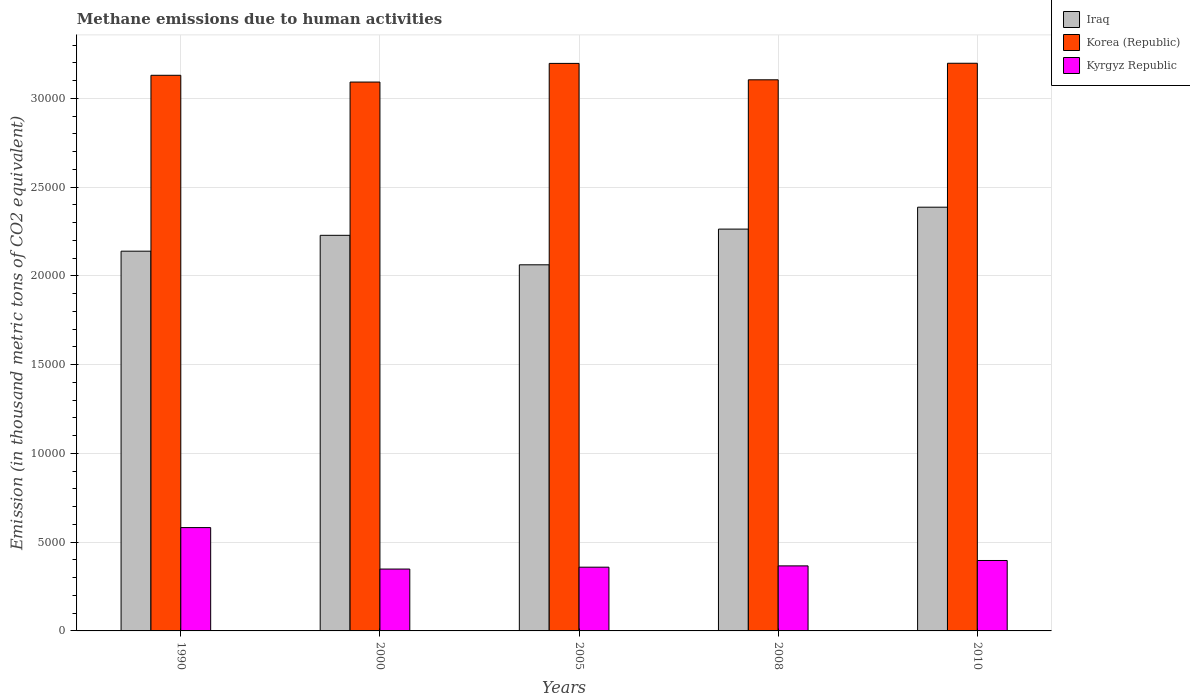How many groups of bars are there?
Give a very brief answer. 5. Are the number of bars on each tick of the X-axis equal?
Offer a very short reply. Yes. In how many cases, is the number of bars for a given year not equal to the number of legend labels?
Provide a succinct answer. 0. What is the amount of methane emitted in Kyrgyz Republic in 1990?
Provide a short and direct response. 5822.6. Across all years, what is the maximum amount of methane emitted in Korea (Republic)?
Offer a terse response. 3.20e+04. Across all years, what is the minimum amount of methane emitted in Kyrgyz Republic?
Offer a terse response. 3485.8. In which year was the amount of methane emitted in Iraq maximum?
Provide a short and direct response. 2010. In which year was the amount of methane emitted in Korea (Republic) minimum?
Ensure brevity in your answer.  2000. What is the total amount of methane emitted in Kyrgyz Republic in the graph?
Your answer should be compact. 2.05e+04. What is the difference between the amount of methane emitted in Korea (Republic) in 2000 and that in 2010?
Your response must be concise. -1058.8. What is the difference between the amount of methane emitted in Korea (Republic) in 2008 and the amount of methane emitted in Kyrgyz Republic in 1990?
Offer a terse response. 2.52e+04. What is the average amount of methane emitted in Korea (Republic) per year?
Give a very brief answer. 3.14e+04. In the year 1990, what is the difference between the amount of methane emitted in Iraq and amount of methane emitted in Korea (Republic)?
Give a very brief answer. -9910.7. In how many years, is the amount of methane emitted in Kyrgyz Republic greater than 9000 thousand metric tons?
Your answer should be compact. 0. What is the ratio of the amount of methane emitted in Korea (Republic) in 2008 to that in 2010?
Keep it short and to the point. 0.97. What is the difference between the highest and the second highest amount of methane emitted in Iraq?
Your answer should be very brief. 1233.8. What is the difference between the highest and the lowest amount of methane emitted in Kyrgyz Republic?
Make the answer very short. 2336.8. Is the sum of the amount of methane emitted in Korea (Republic) in 1990 and 2008 greater than the maximum amount of methane emitted in Iraq across all years?
Ensure brevity in your answer.  Yes. What does the 3rd bar from the left in 2000 represents?
Offer a very short reply. Kyrgyz Republic. What does the 3rd bar from the right in 2010 represents?
Keep it short and to the point. Iraq. Is it the case that in every year, the sum of the amount of methane emitted in Korea (Republic) and amount of methane emitted in Kyrgyz Republic is greater than the amount of methane emitted in Iraq?
Provide a short and direct response. Yes. How many bars are there?
Your response must be concise. 15. Are all the bars in the graph horizontal?
Your answer should be very brief. No. How many years are there in the graph?
Give a very brief answer. 5. Are the values on the major ticks of Y-axis written in scientific E-notation?
Your answer should be very brief. No. Does the graph contain grids?
Provide a succinct answer. Yes. What is the title of the graph?
Ensure brevity in your answer.  Methane emissions due to human activities. What is the label or title of the Y-axis?
Your response must be concise. Emission (in thousand metric tons of CO2 equivalent). What is the Emission (in thousand metric tons of CO2 equivalent) of Iraq in 1990?
Offer a terse response. 2.14e+04. What is the Emission (in thousand metric tons of CO2 equivalent) of Korea (Republic) in 1990?
Offer a very short reply. 3.13e+04. What is the Emission (in thousand metric tons of CO2 equivalent) of Kyrgyz Republic in 1990?
Your answer should be very brief. 5822.6. What is the Emission (in thousand metric tons of CO2 equivalent) of Iraq in 2000?
Your response must be concise. 2.23e+04. What is the Emission (in thousand metric tons of CO2 equivalent) of Korea (Republic) in 2000?
Provide a short and direct response. 3.09e+04. What is the Emission (in thousand metric tons of CO2 equivalent) in Kyrgyz Republic in 2000?
Keep it short and to the point. 3485.8. What is the Emission (in thousand metric tons of CO2 equivalent) of Iraq in 2005?
Ensure brevity in your answer.  2.06e+04. What is the Emission (in thousand metric tons of CO2 equivalent) in Korea (Republic) in 2005?
Ensure brevity in your answer.  3.20e+04. What is the Emission (in thousand metric tons of CO2 equivalent) in Kyrgyz Republic in 2005?
Give a very brief answer. 3591.3. What is the Emission (in thousand metric tons of CO2 equivalent) in Iraq in 2008?
Ensure brevity in your answer.  2.26e+04. What is the Emission (in thousand metric tons of CO2 equivalent) in Korea (Republic) in 2008?
Your answer should be compact. 3.11e+04. What is the Emission (in thousand metric tons of CO2 equivalent) in Kyrgyz Republic in 2008?
Provide a short and direct response. 3664.5. What is the Emission (in thousand metric tons of CO2 equivalent) in Iraq in 2010?
Offer a terse response. 2.39e+04. What is the Emission (in thousand metric tons of CO2 equivalent) in Korea (Republic) in 2010?
Provide a succinct answer. 3.20e+04. What is the Emission (in thousand metric tons of CO2 equivalent) in Kyrgyz Republic in 2010?
Offer a terse response. 3968.4. Across all years, what is the maximum Emission (in thousand metric tons of CO2 equivalent) of Iraq?
Make the answer very short. 2.39e+04. Across all years, what is the maximum Emission (in thousand metric tons of CO2 equivalent) of Korea (Republic)?
Provide a succinct answer. 3.20e+04. Across all years, what is the maximum Emission (in thousand metric tons of CO2 equivalent) in Kyrgyz Republic?
Your answer should be very brief. 5822.6. Across all years, what is the minimum Emission (in thousand metric tons of CO2 equivalent) of Iraq?
Offer a terse response. 2.06e+04. Across all years, what is the minimum Emission (in thousand metric tons of CO2 equivalent) in Korea (Republic)?
Provide a succinct answer. 3.09e+04. Across all years, what is the minimum Emission (in thousand metric tons of CO2 equivalent) in Kyrgyz Republic?
Keep it short and to the point. 3485.8. What is the total Emission (in thousand metric tons of CO2 equivalent) in Iraq in the graph?
Provide a succinct answer. 1.11e+05. What is the total Emission (in thousand metric tons of CO2 equivalent) in Korea (Republic) in the graph?
Provide a short and direct response. 1.57e+05. What is the total Emission (in thousand metric tons of CO2 equivalent) of Kyrgyz Republic in the graph?
Ensure brevity in your answer.  2.05e+04. What is the difference between the Emission (in thousand metric tons of CO2 equivalent) in Iraq in 1990 and that in 2000?
Keep it short and to the point. -893.7. What is the difference between the Emission (in thousand metric tons of CO2 equivalent) in Korea (Republic) in 1990 and that in 2000?
Ensure brevity in your answer.  381.1. What is the difference between the Emission (in thousand metric tons of CO2 equivalent) in Kyrgyz Republic in 1990 and that in 2000?
Your response must be concise. 2336.8. What is the difference between the Emission (in thousand metric tons of CO2 equivalent) of Iraq in 1990 and that in 2005?
Your response must be concise. 767.2. What is the difference between the Emission (in thousand metric tons of CO2 equivalent) of Korea (Republic) in 1990 and that in 2005?
Provide a short and direct response. -669.8. What is the difference between the Emission (in thousand metric tons of CO2 equivalent) of Kyrgyz Republic in 1990 and that in 2005?
Make the answer very short. 2231.3. What is the difference between the Emission (in thousand metric tons of CO2 equivalent) in Iraq in 1990 and that in 2008?
Your response must be concise. -1244.7. What is the difference between the Emission (in thousand metric tons of CO2 equivalent) in Korea (Republic) in 1990 and that in 2008?
Give a very brief answer. 254.6. What is the difference between the Emission (in thousand metric tons of CO2 equivalent) of Kyrgyz Republic in 1990 and that in 2008?
Keep it short and to the point. 2158.1. What is the difference between the Emission (in thousand metric tons of CO2 equivalent) of Iraq in 1990 and that in 2010?
Offer a very short reply. -2478.5. What is the difference between the Emission (in thousand metric tons of CO2 equivalent) in Korea (Republic) in 1990 and that in 2010?
Your answer should be very brief. -677.7. What is the difference between the Emission (in thousand metric tons of CO2 equivalent) in Kyrgyz Republic in 1990 and that in 2010?
Provide a succinct answer. 1854.2. What is the difference between the Emission (in thousand metric tons of CO2 equivalent) in Iraq in 2000 and that in 2005?
Make the answer very short. 1660.9. What is the difference between the Emission (in thousand metric tons of CO2 equivalent) of Korea (Republic) in 2000 and that in 2005?
Give a very brief answer. -1050.9. What is the difference between the Emission (in thousand metric tons of CO2 equivalent) of Kyrgyz Republic in 2000 and that in 2005?
Make the answer very short. -105.5. What is the difference between the Emission (in thousand metric tons of CO2 equivalent) in Iraq in 2000 and that in 2008?
Offer a very short reply. -351. What is the difference between the Emission (in thousand metric tons of CO2 equivalent) in Korea (Republic) in 2000 and that in 2008?
Ensure brevity in your answer.  -126.5. What is the difference between the Emission (in thousand metric tons of CO2 equivalent) in Kyrgyz Republic in 2000 and that in 2008?
Your response must be concise. -178.7. What is the difference between the Emission (in thousand metric tons of CO2 equivalent) of Iraq in 2000 and that in 2010?
Your response must be concise. -1584.8. What is the difference between the Emission (in thousand metric tons of CO2 equivalent) in Korea (Republic) in 2000 and that in 2010?
Your answer should be very brief. -1058.8. What is the difference between the Emission (in thousand metric tons of CO2 equivalent) in Kyrgyz Republic in 2000 and that in 2010?
Provide a short and direct response. -482.6. What is the difference between the Emission (in thousand metric tons of CO2 equivalent) in Iraq in 2005 and that in 2008?
Your answer should be compact. -2011.9. What is the difference between the Emission (in thousand metric tons of CO2 equivalent) in Korea (Republic) in 2005 and that in 2008?
Provide a short and direct response. 924.4. What is the difference between the Emission (in thousand metric tons of CO2 equivalent) of Kyrgyz Republic in 2005 and that in 2008?
Your answer should be very brief. -73.2. What is the difference between the Emission (in thousand metric tons of CO2 equivalent) in Iraq in 2005 and that in 2010?
Ensure brevity in your answer.  -3245.7. What is the difference between the Emission (in thousand metric tons of CO2 equivalent) in Korea (Republic) in 2005 and that in 2010?
Keep it short and to the point. -7.9. What is the difference between the Emission (in thousand metric tons of CO2 equivalent) of Kyrgyz Republic in 2005 and that in 2010?
Offer a very short reply. -377.1. What is the difference between the Emission (in thousand metric tons of CO2 equivalent) in Iraq in 2008 and that in 2010?
Provide a succinct answer. -1233.8. What is the difference between the Emission (in thousand metric tons of CO2 equivalent) of Korea (Republic) in 2008 and that in 2010?
Offer a terse response. -932.3. What is the difference between the Emission (in thousand metric tons of CO2 equivalent) of Kyrgyz Republic in 2008 and that in 2010?
Keep it short and to the point. -303.9. What is the difference between the Emission (in thousand metric tons of CO2 equivalent) of Iraq in 1990 and the Emission (in thousand metric tons of CO2 equivalent) of Korea (Republic) in 2000?
Provide a succinct answer. -9529.6. What is the difference between the Emission (in thousand metric tons of CO2 equivalent) in Iraq in 1990 and the Emission (in thousand metric tons of CO2 equivalent) in Kyrgyz Republic in 2000?
Your response must be concise. 1.79e+04. What is the difference between the Emission (in thousand metric tons of CO2 equivalent) in Korea (Republic) in 1990 and the Emission (in thousand metric tons of CO2 equivalent) in Kyrgyz Republic in 2000?
Give a very brief answer. 2.78e+04. What is the difference between the Emission (in thousand metric tons of CO2 equivalent) of Iraq in 1990 and the Emission (in thousand metric tons of CO2 equivalent) of Korea (Republic) in 2005?
Your response must be concise. -1.06e+04. What is the difference between the Emission (in thousand metric tons of CO2 equivalent) of Iraq in 1990 and the Emission (in thousand metric tons of CO2 equivalent) of Kyrgyz Republic in 2005?
Provide a succinct answer. 1.78e+04. What is the difference between the Emission (in thousand metric tons of CO2 equivalent) of Korea (Republic) in 1990 and the Emission (in thousand metric tons of CO2 equivalent) of Kyrgyz Republic in 2005?
Make the answer very short. 2.77e+04. What is the difference between the Emission (in thousand metric tons of CO2 equivalent) of Iraq in 1990 and the Emission (in thousand metric tons of CO2 equivalent) of Korea (Republic) in 2008?
Your answer should be very brief. -9656.1. What is the difference between the Emission (in thousand metric tons of CO2 equivalent) of Iraq in 1990 and the Emission (in thousand metric tons of CO2 equivalent) of Kyrgyz Republic in 2008?
Provide a succinct answer. 1.77e+04. What is the difference between the Emission (in thousand metric tons of CO2 equivalent) in Korea (Republic) in 1990 and the Emission (in thousand metric tons of CO2 equivalent) in Kyrgyz Republic in 2008?
Offer a very short reply. 2.76e+04. What is the difference between the Emission (in thousand metric tons of CO2 equivalent) of Iraq in 1990 and the Emission (in thousand metric tons of CO2 equivalent) of Korea (Republic) in 2010?
Your answer should be very brief. -1.06e+04. What is the difference between the Emission (in thousand metric tons of CO2 equivalent) in Iraq in 1990 and the Emission (in thousand metric tons of CO2 equivalent) in Kyrgyz Republic in 2010?
Provide a succinct answer. 1.74e+04. What is the difference between the Emission (in thousand metric tons of CO2 equivalent) in Korea (Republic) in 1990 and the Emission (in thousand metric tons of CO2 equivalent) in Kyrgyz Republic in 2010?
Your answer should be very brief. 2.73e+04. What is the difference between the Emission (in thousand metric tons of CO2 equivalent) in Iraq in 2000 and the Emission (in thousand metric tons of CO2 equivalent) in Korea (Republic) in 2005?
Keep it short and to the point. -9686.8. What is the difference between the Emission (in thousand metric tons of CO2 equivalent) of Iraq in 2000 and the Emission (in thousand metric tons of CO2 equivalent) of Kyrgyz Republic in 2005?
Make the answer very short. 1.87e+04. What is the difference between the Emission (in thousand metric tons of CO2 equivalent) in Korea (Republic) in 2000 and the Emission (in thousand metric tons of CO2 equivalent) in Kyrgyz Republic in 2005?
Your answer should be compact. 2.73e+04. What is the difference between the Emission (in thousand metric tons of CO2 equivalent) of Iraq in 2000 and the Emission (in thousand metric tons of CO2 equivalent) of Korea (Republic) in 2008?
Provide a short and direct response. -8762.4. What is the difference between the Emission (in thousand metric tons of CO2 equivalent) of Iraq in 2000 and the Emission (in thousand metric tons of CO2 equivalent) of Kyrgyz Republic in 2008?
Ensure brevity in your answer.  1.86e+04. What is the difference between the Emission (in thousand metric tons of CO2 equivalent) of Korea (Republic) in 2000 and the Emission (in thousand metric tons of CO2 equivalent) of Kyrgyz Republic in 2008?
Your answer should be very brief. 2.73e+04. What is the difference between the Emission (in thousand metric tons of CO2 equivalent) of Iraq in 2000 and the Emission (in thousand metric tons of CO2 equivalent) of Korea (Republic) in 2010?
Provide a short and direct response. -9694.7. What is the difference between the Emission (in thousand metric tons of CO2 equivalent) of Iraq in 2000 and the Emission (in thousand metric tons of CO2 equivalent) of Kyrgyz Republic in 2010?
Provide a short and direct response. 1.83e+04. What is the difference between the Emission (in thousand metric tons of CO2 equivalent) of Korea (Republic) in 2000 and the Emission (in thousand metric tons of CO2 equivalent) of Kyrgyz Republic in 2010?
Keep it short and to the point. 2.70e+04. What is the difference between the Emission (in thousand metric tons of CO2 equivalent) in Iraq in 2005 and the Emission (in thousand metric tons of CO2 equivalent) in Korea (Republic) in 2008?
Provide a short and direct response. -1.04e+04. What is the difference between the Emission (in thousand metric tons of CO2 equivalent) of Iraq in 2005 and the Emission (in thousand metric tons of CO2 equivalent) of Kyrgyz Republic in 2008?
Your response must be concise. 1.70e+04. What is the difference between the Emission (in thousand metric tons of CO2 equivalent) of Korea (Republic) in 2005 and the Emission (in thousand metric tons of CO2 equivalent) of Kyrgyz Republic in 2008?
Give a very brief answer. 2.83e+04. What is the difference between the Emission (in thousand metric tons of CO2 equivalent) in Iraq in 2005 and the Emission (in thousand metric tons of CO2 equivalent) in Korea (Republic) in 2010?
Offer a very short reply. -1.14e+04. What is the difference between the Emission (in thousand metric tons of CO2 equivalent) in Iraq in 2005 and the Emission (in thousand metric tons of CO2 equivalent) in Kyrgyz Republic in 2010?
Provide a succinct answer. 1.67e+04. What is the difference between the Emission (in thousand metric tons of CO2 equivalent) in Korea (Republic) in 2005 and the Emission (in thousand metric tons of CO2 equivalent) in Kyrgyz Republic in 2010?
Ensure brevity in your answer.  2.80e+04. What is the difference between the Emission (in thousand metric tons of CO2 equivalent) of Iraq in 2008 and the Emission (in thousand metric tons of CO2 equivalent) of Korea (Republic) in 2010?
Give a very brief answer. -9343.7. What is the difference between the Emission (in thousand metric tons of CO2 equivalent) in Iraq in 2008 and the Emission (in thousand metric tons of CO2 equivalent) in Kyrgyz Republic in 2010?
Keep it short and to the point. 1.87e+04. What is the difference between the Emission (in thousand metric tons of CO2 equivalent) of Korea (Republic) in 2008 and the Emission (in thousand metric tons of CO2 equivalent) of Kyrgyz Republic in 2010?
Give a very brief answer. 2.71e+04. What is the average Emission (in thousand metric tons of CO2 equivalent) of Iraq per year?
Your answer should be compact. 2.22e+04. What is the average Emission (in thousand metric tons of CO2 equivalent) of Korea (Republic) per year?
Give a very brief answer. 3.14e+04. What is the average Emission (in thousand metric tons of CO2 equivalent) of Kyrgyz Republic per year?
Your response must be concise. 4106.52. In the year 1990, what is the difference between the Emission (in thousand metric tons of CO2 equivalent) in Iraq and Emission (in thousand metric tons of CO2 equivalent) in Korea (Republic)?
Your response must be concise. -9910.7. In the year 1990, what is the difference between the Emission (in thousand metric tons of CO2 equivalent) of Iraq and Emission (in thousand metric tons of CO2 equivalent) of Kyrgyz Republic?
Offer a terse response. 1.56e+04. In the year 1990, what is the difference between the Emission (in thousand metric tons of CO2 equivalent) in Korea (Republic) and Emission (in thousand metric tons of CO2 equivalent) in Kyrgyz Republic?
Your answer should be very brief. 2.55e+04. In the year 2000, what is the difference between the Emission (in thousand metric tons of CO2 equivalent) of Iraq and Emission (in thousand metric tons of CO2 equivalent) of Korea (Republic)?
Provide a short and direct response. -8635.9. In the year 2000, what is the difference between the Emission (in thousand metric tons of CO2 equivalent) of Iraq and Emission (in thousand metric tons of CO2 equivalent) of Kyrgyz Republic?
Your answer should be compact. 1.88e+04. In the year 2000, what is the difference between the Emission (in thousand metric tons of CO2 equivalent) of Korea (Republic) and Emission (in thousand metric tons of CO2 equivalent) of Kyrgyz Republic?
Keep it short and to the point. 2.74e+04. In the year 2005, what is the difference between the Emission (in thousand metric tons of CO2 equivalent) in Iraq and Emission (in thousand metric tons of CO2 equivalent) in Korea (Republic)?
Your response must be concise. -1.13e+04. In the year 2005, what is the difference between the Emission (in thousand metric tons of CO2 equivalent) of Iraq and Emission (in thousand metric tons of CO2 equivalent) of Kyrgyz Republic?
Offer a very short reply. 1.70e+04. In the year 2005, what is the difference between the Emission (in thousand metric tons of CO2 equivalent) of Korea (Republic) and Emission (in thousand metric tons of CO2 equivalent) of Kyrgyz Republic?
Keep it short and to the point. 2.84e+04. In the year 2008, what is the difference between the Emission (in thousand metric tons of CO2 equivalent) of Iraq and Emission (in thousand metric tons of CO2 equivalent) of Korea (Republic)?
Ensure brevity in your answer.  -8411.4. In the year 2008, what is the difference between the Emission (in thousand metric tons of CO2 equivalent) in Iraq and Emission (in thousand metric tons of CO2 equivalent) in Kyrgyz Republic?
Provide a succinct answer. 1.90e+04. In the year 2008, what is the difference between the Emission (in thousand metric tons of CO2 equivalent) of Korea (Republic) and Emission (in thousand metric tons of CO2 equivalent) of Kyrgyz Republic?
Offer a very short reply. 2.74e+04. In the year 2010, what is the difference between the Emission (in thousand metric tons of CO2 equivalent) of Iraq and Emission (in thousand metric tons of CO2 equivalent) of Korea (Republic)?
Your answer should be very brief. -8109.9. In the year 2010, what is the difference between the Emission (in thousand metric tons of CO2 equivalent) in Iraq and Emission (in thousand metric tons of CO2 equivalent) in Kyrgyz Republic?
Offer a very short reply. 1.99e+04. In the year 2010, what is the difference between the Emission (in thousand metric tons of CO2 equivalent) of Korea (Republic) and Emission (in thousand metric tons of CO2 equivalent) of Kyrgyz Republic?
Your answer should be compact. 2.80e+04. What is the ratio of the Emission (in thousand metric tons of CO2 equivalent) in Iraq in 1990 to that in 2000?
Provide a short and direct response. 0.96. What is the ratio of the Emission (in thousand metric tons of CO2 equivalent) in Korea (Republic) in 1990 to that in 2000?
Give a very brief answer. 1.01. What is the ratio of the Emission (in thousand metric tons of CO2 equivalent) in Kyrgyz Republic in 1990 to that in 2000?
Your response must be concise. 1.67. What is the ratio of the Emission (in thousand metric tons of CO2 equivalent) of Iraq in 1990 to that in 2005?
Provide a succinct answer. 1.04. What is the ratio of the Emission (in thousand metric tons of CO2 equivalent) of Korea (Republic) in 1990 to that in 2005?
Your response must be concise. 0.98. What is the ratio of the Emission (in thousand metric tons of CO2 equivalent) of Kyrgyz Republic in 1990 to that in 2005?
Offer a terse response. 1.62. What is the ratio of the Emission (in thousand metric tons of CO2 equivalent) in Iraq in 1990 to that in 2008?
Provide a short and direct response. 0.94. What is the ratio of the Emission (in thousand metric tons of CO2 equivalent) of Korea (Republic) in 1990 to that in 2008?
Make the answer very short. 1.01. What is the ratio of the Emission (in thousand metric tons of CO2 equivalent) in Kyrgyz Republic in 1990 to that in 2008?
Give a very brief answer. 1.59. What is the ratio of the Emission (in thousand metric tons of CO2 equivalent) in Iraq in 1990 to that in 2010?
Provide a succinct answer. 0.9. What is the ratio of the Emission (in thousand metric tons of CO2 equivalent) of Korea (Republic) in 1990 to that in 2010?
Make the answer very short. 0.98. What is the ratio of the Emission (in thousand metric tons of CO2 equivalent) of Kyrgyz Republic in 1990 to that in 2010?
Offer a very short reply. 1.47. What is the ratio of the Emission (in thousand metric tons of CO2 equivalent) of Iraq in 2000 to that in 2005?
Make the answer very short. 1.08. What is the ratio of the Emission (in thousand metric tons of CO2 equivalent) of Korea (Republic) in 2000 to that in 2005?
Offer a very short reply. 0.97. What is the ratio of the Emission (in thousand metric tons of CO2 equivalent) of Kyrgyz Republic in 2000 to that in 2005?
Your response must be concise. 0.97. What is the ratio of the Emission (in thousand metric tons of CO2 equivalent) in Iraq in 2000 to that in 2008?
Provide a short and direct response. 0.98. What is the ratio of the Emission (in thousand metric tons of CO2 equivalent) of Korea (Republic) in 2000 to that in 2008?
Give a very brief answer. 1. What is the ratio of the Emission (in thousand metric tons of CO2 equivalent) of Kyrgyz Republic in 2000 to that in 2008?
Ensure brevity in your answer.  0.95. What is the ratio of the Emission (in thousand metric tons of CO2 equivalent) of Iraq in 2000 to that in 2010?
Your answer should be compact. 0.93. What is the ratio of the Emission (in thousand metric tons of CO2 equivalent) in Korea (Republic) in 2000 to that in 2010?
Your response must be concise. 0.97. What is the ratio of the Emission (in thousand metric tons of CO2 equivalent) of Kyrgyz Republic in 2000 to that in 2010?
Offer a terse response. 0.88. What is the ratio of the Emission (in thousand metric tons of CO2 equivalent) in Iraq in 2005 to that in 2008?
Give a very brief answer. 0.91. What is the ratio of the Emission (in thousand metric tons of CO2 equivalent) of Korea (Republic) in 2005 to that in 2008?
Provide a succinct answer. 1.03. What is the ratio of the Emission (in thousand metric tons of CO2 equivalent) in Iraq in 2005 to that in 2010?
Your answer should be compact. 0.86. What is the ratio of the Emission (in thousand metric tons of CO2 equivalent) in Kyrgyz Republic in 2005 to that in 2010?
Provide a succinct answer. 0.91. What is the ratio of the Emission (in thousand metric tons of CO2 equivalent) in Iraq in 2008 to that in 2010?
Give a very brief answer. 0.95. What is the ratio of the Emission (in thousand metric tons of CO2 equivalent) in Korea (Republic) in 2008 to that in 2010?
Make the answer very short. 0.97. What is the ratio of the Emission (in thousand metric tons of CO2 equivalent) of Kyrgyz Republic in 2008 to that in 2010?
Provide a short and direct response. 0.92. What is the difference between the highest and the second highest Emission (in thousand metric tons of CO2 equivalent) of Iraq?
Your answer should be compact. 1233.8. What is the difference between the highest and the second highest Emission (in thousand metric tons of CO2 equivalent) of Korea (Republic)?
Offer a terse response. 7.9. What is the difference between the highest and the second highest Emission (in thousand metric tons of CO2 equivalent) in Kyrgyz Republic?
Offer a very short reply. 1854.2. What is the difference between the highest and the lowest Emission (in thousand metric tons of CO2 equivalent) of Iraq?
Make the answer very short. 3245.7. What is the difference between the highest and the lowest Emission (in thousand metric tons of CO2 equivalent) of Korea (Republic)?
Your response must be concise. 1058.8. What is the difference between the highest and the lowest Emission (in thousand metric tons of CO2 equivalent) of Kyrgyz Republic?
Your answer should be very brief. 2336.8. 